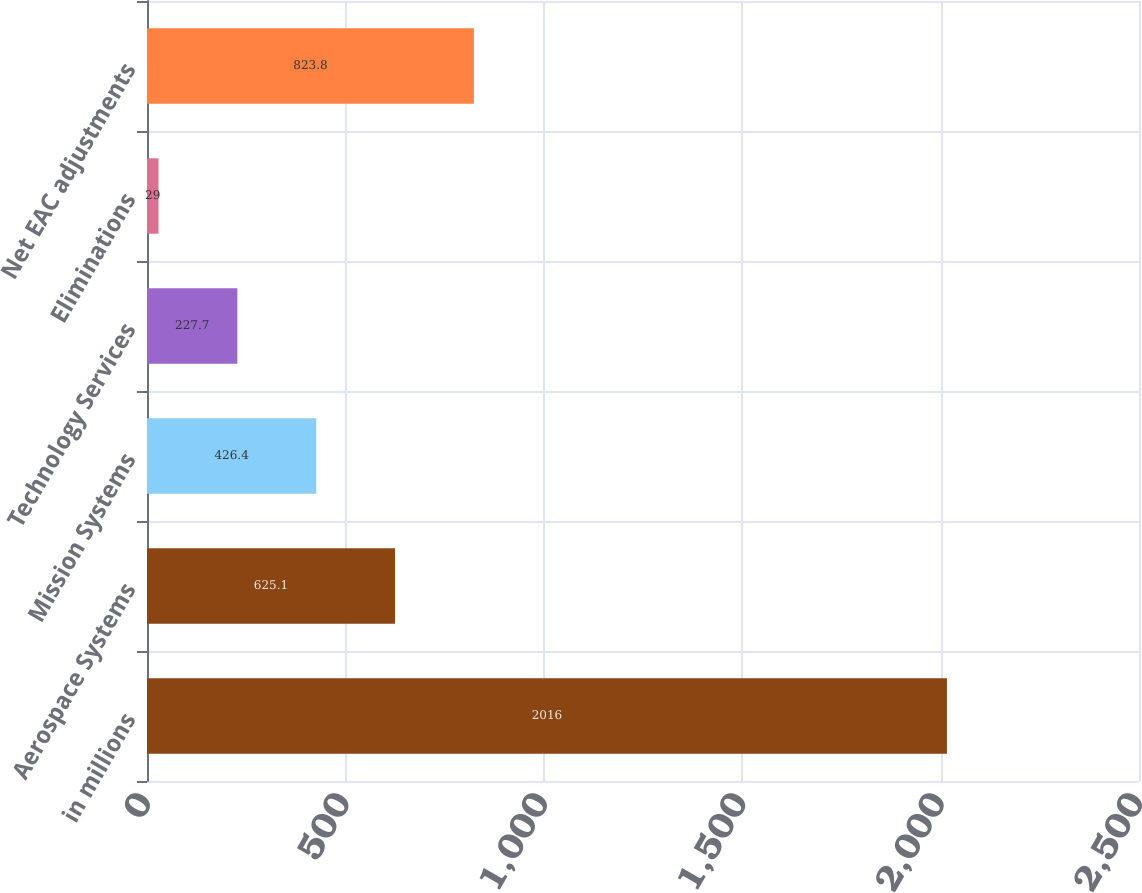Convert chart to OTSL. <chart><loc_0><loc_0><loc_500><loc_500><bar_chart><fcel>in millions<fcel>Aerospace Systems<fcel>Mission Systems<fcel>Technology Services<fcel>Eliminations<fcel>Net EAC adjustments<nl><fcel>2016<fcel>625.1<fcel>426.4<fcel>227.7<fcel>29<fcel>823.8<nl></chart> 